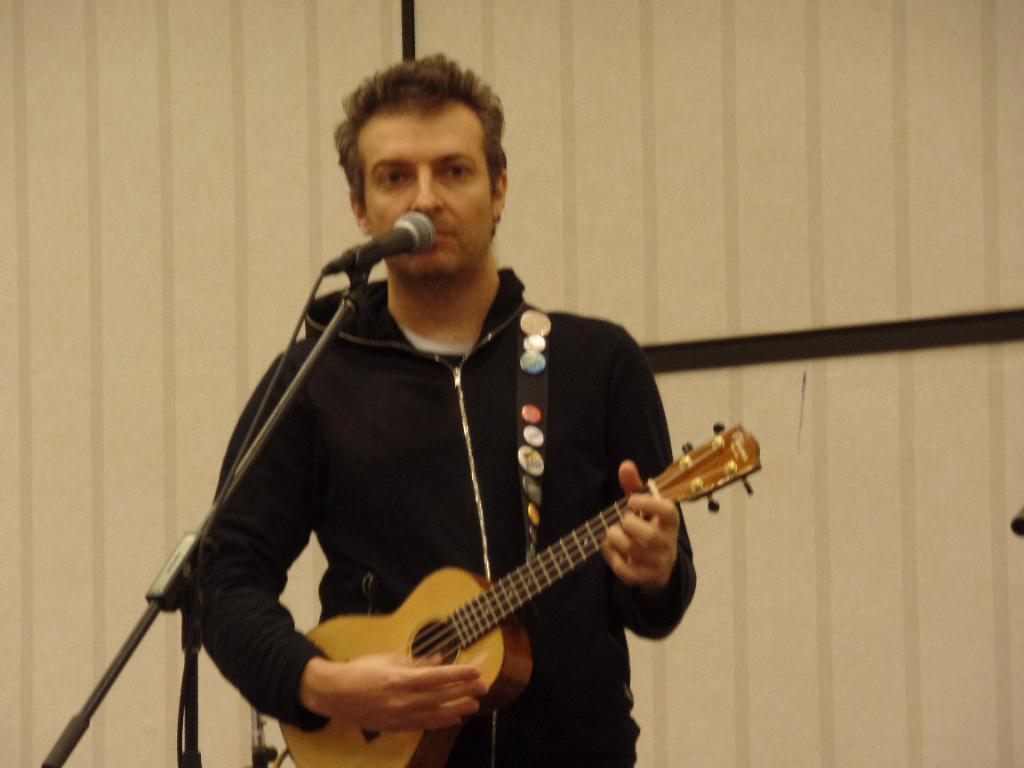Please provide a concise description of this image. In this image I can see the person standing in front of the mic and holding the guitar. At the back of him there is a wall. 